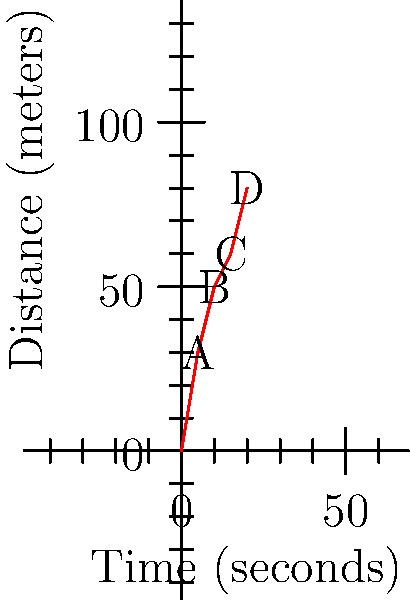The graph shows the distance-time relationship for a dog completing an agility course. Calculate the dog's average velocity between points B and D of the run. To calculate the average velocity, we need to use the formula:

$$ v = \frac{\Delta d}{\Delta t} $$

Where $v$ is velocity, $\Delta d$ is change in distance, and $\Delta t$ is change in time.

Step 1: Determine the change in distance ($\Delta d$)
- Distance at point D: 80 meters
- Distance at point B: 50 meters
$\Delta d = 80 - 50 = 30$ meters

Step 2: Determine the change in time ($\Delta t$)
- Time at point D: 20 seconds
- Time at point B: 10 seconds
$\Delta t = 20 - 10 = 10$ seconds

Step 3: Apply the velocity formula
$$ v = \frac{\Delta d}{\Delta t} = \frac{30 \text{ meters}}{10 \text{ seconds}} = 3 \text{ m/s} $$

Therefore, the dog's average velocity between points B and D is 3 meters per second.
Answer: 3 m/s 